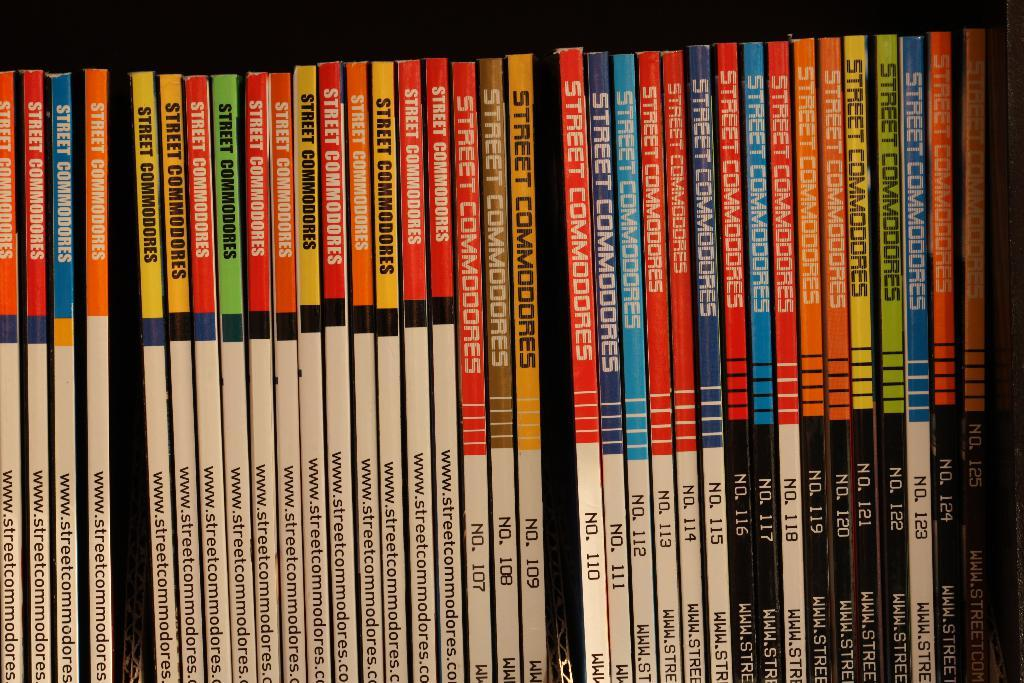Provide a one-sentence caption for the provided image. A collection of Street Commanders books sit on a shelf sorted by volumes. 